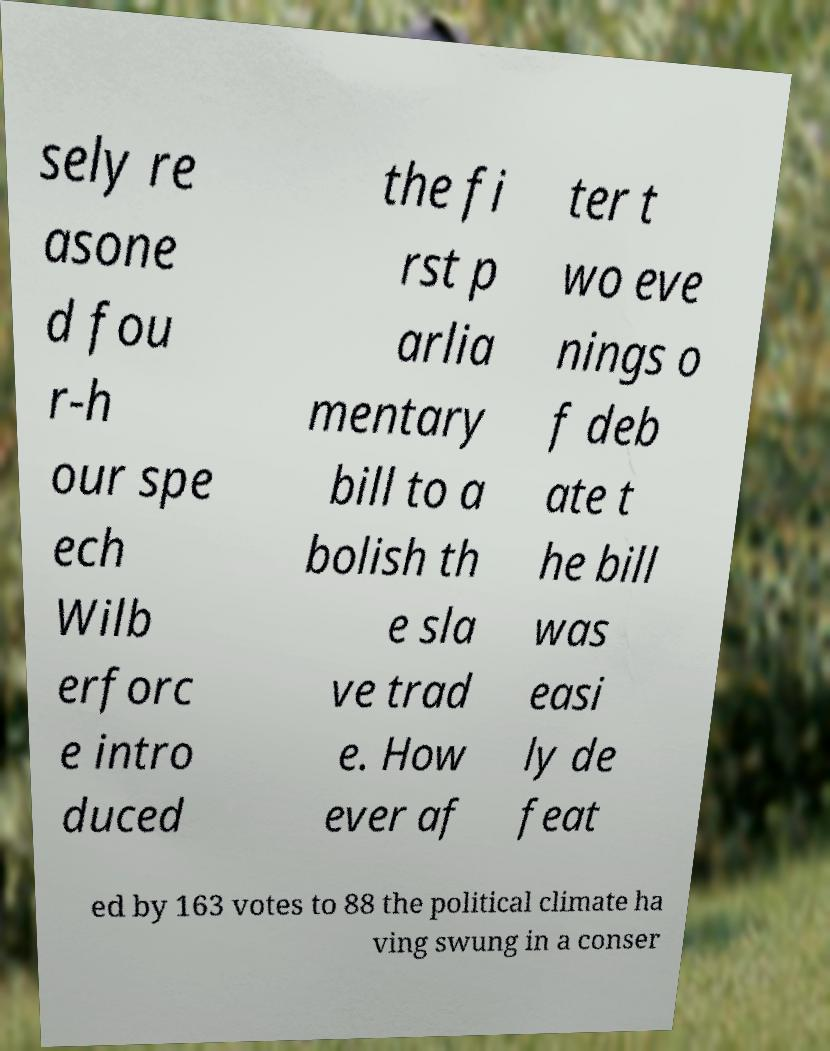Please read and relay the text visible in this image. What does it say? sely re asone d fou r-h our spe ech Wilb erforc e intro duced the fi rst p arlia mentary bill to a bolish th e sla ve trad e. How ever af ter t wo eve nings o f deb ate t he bill was easi ly de feat ed by 163 votes to 88 the political climate ha ving swung in a conser 